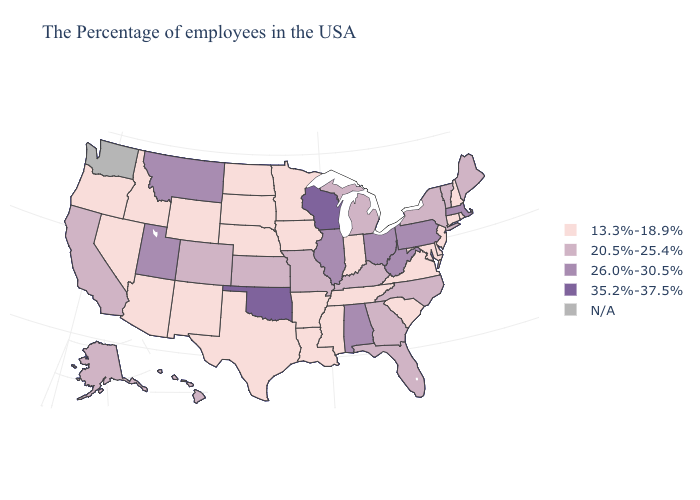Name the states that have a value in the range 20.5%-25.4%?
Quick response, please. Maine, Vermont, New York, North Carolina, Florida, Georgia, Michigan, Kentucky, Missouri, Kansas, Colorado, California, Alaska, Hawaii. Which states have the lowest value in the West?
Concise answer only. Wyoming, New Mexico, Arizona, Idaho, Nevada, Oregon. Does Maine have the highest value in the Northeast?
Quick response, please. No. Which states have the lowest value in the USA?
Short answer required. Rhode Island, New Hampshire, Connecticut, New Jersey, Delaware, Maryland, Virginia, South Carolina, Indiana, Tennessee, Mississippi, Louisiana, Arkansas, Minnesota, Iowa, Nebraska, Texas, South Dakota, North Dakota, Wyoming, New Mexico, Arizona, Idaho, Nevada, Oregon. Does New Hampshire have the lowest value in the USA?
Quick response, please. Yes. What is the lowest value in states that border Minnesota?
Quick response, please. 13.3%-18.9%. Does the first symbol in the legend represent the smallest category?
Quick response, please. Yes. What is the value of Oklahoma?
Write a very short answer. 35.2%-37.5%. Is the legend a continuous bar?
Write a very short answer. No. Name the states that have a value in the range 20.5%-25.4%?
Answer briefly. Maine, Vermont, New York, North Carolina, Florida, Georgia, Michigan, Kentucky, Missouri, Kansas, Colorado, California, Alaska, Hawaii. Name the states that have a value in the range 20.5%-25.4%?
Be succinct. Maine, Vermont, New York, North Carolina, Florida, Georgia, Michigan, Kentucky, Missouri, Kansas, Colorado, California, Alaska, Hawaii. Does Pennsylvania have the lowest value in the Northeast?
Answer briefly. No. Among the states that border Florida , which have the lowest value?
Give a very brief answer. Georgia. What is the value of Alaska?
Quick response, please. 20.5%-25.4%. 